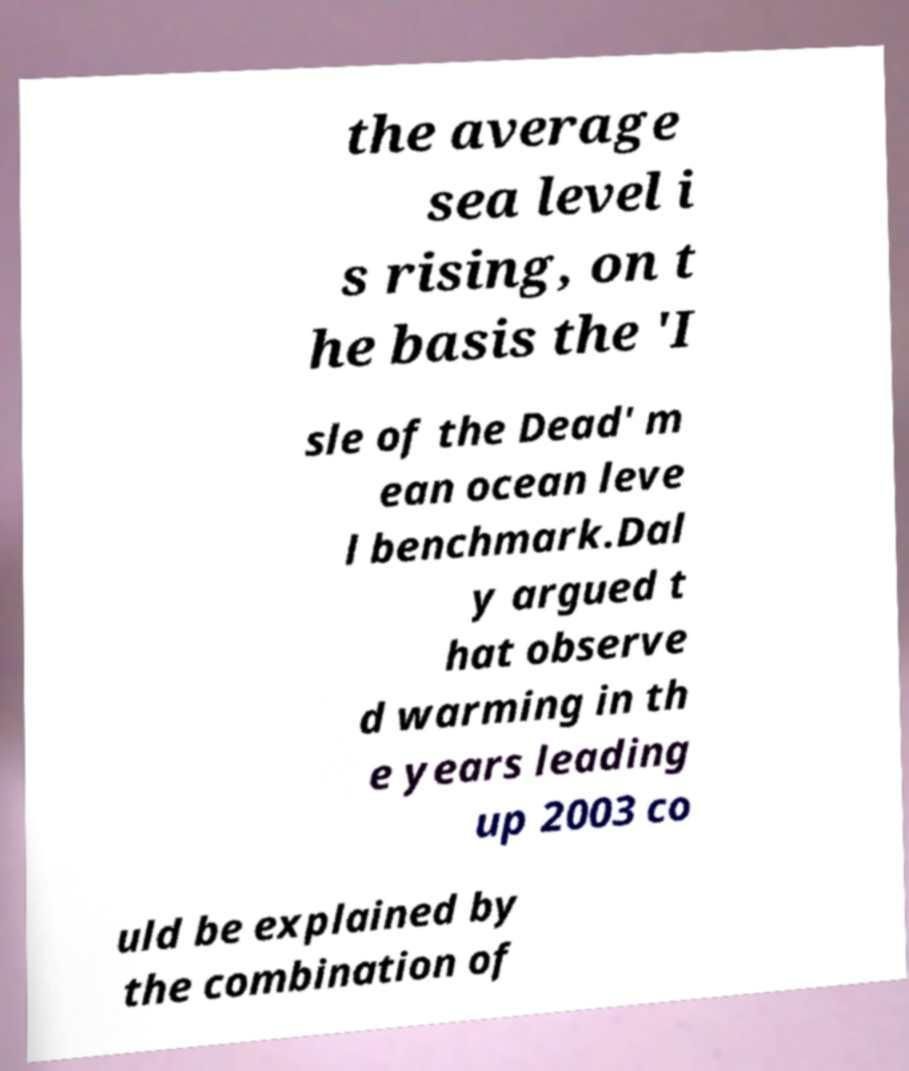There's text embedded in this image that I need extracted. Can you transcribe it verbatim? the average sea level i s rising, on t he basis the 'I sle of the Dead' m ean ocean leve l benchmark.Dal y argued t hat observe d warming in th e years leading up 2003 co uld be explained by the combination of 